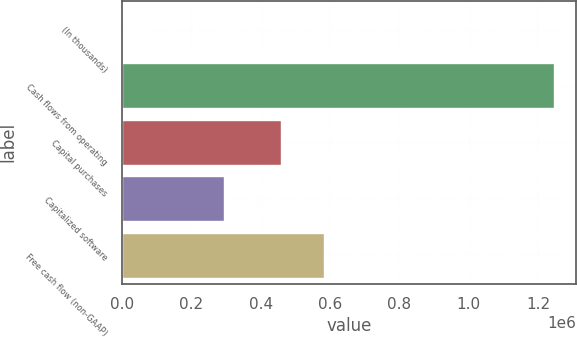<chart> <loc_0><loc_0><loc_500><loc_500><bar_chart><fcel>(In thousands)<fcel>Cash flows from operating<fcel>Capital purchases<fcel>Capitalized software<fcel>Free cash flow (non-GAAP)<nl><fcel>2016<fcel>1.24564e+06<fcel>459427<fcel>293696<fcel>583789<nl></chart> 